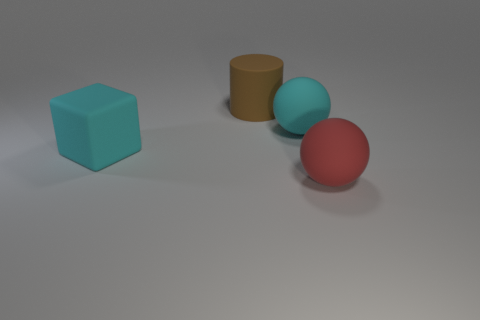Add 1 tiny metallic spheres. How many objects exist? 5 Subtract all blocks. How many objects are left? 3 Add 1 large red balls. How many large red balls exist? 2 Subtract 0 yellow cubes. How many objects are left? 4 Subtract all rubber things. Subtract all large gray matte blocks. How many objects are left? 0 Add 4 large rubber cylinders. How many large rubber cylinders are left? 5 